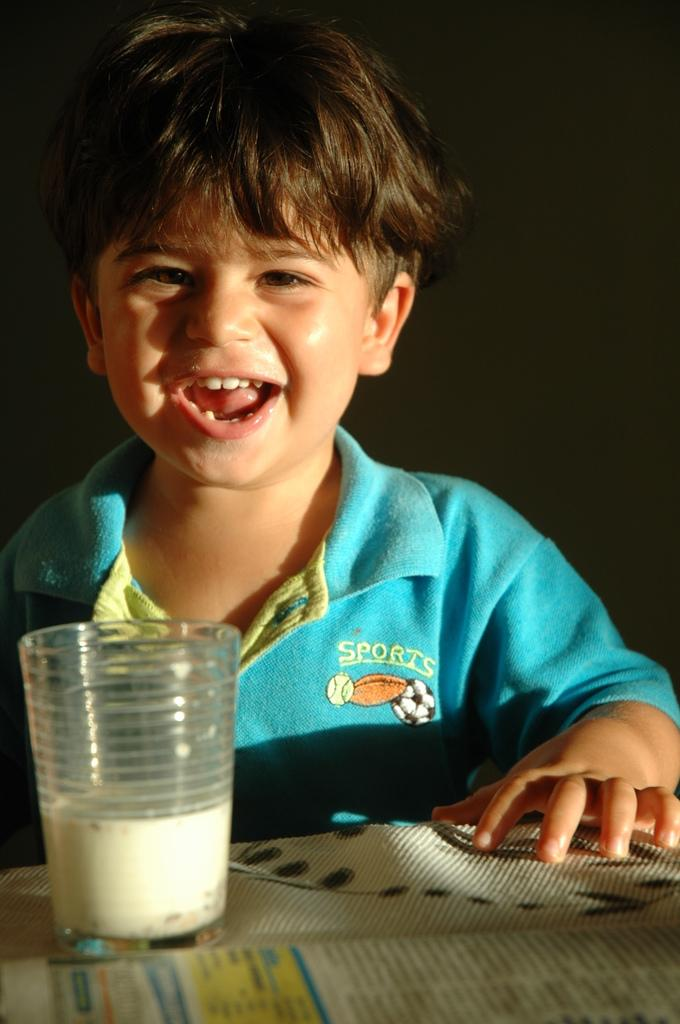Who is the main subject in the picture? There is a boy in the picture. What object is on the table in the image? There is a glass on a table in the picture. What can be seen at the bottom of the picture? There appears to be a paper with text at the bottom of the picture. How would you describe the lighting in the image? The background of the image is dark. What type of tool is the carpenter using in the image? There is no carpenter or tool present in the image. How many eggs are visible in the image? There are no eggs visible in the image. 